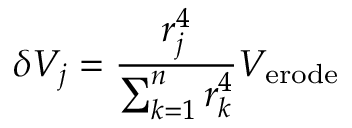Convert formula to latex. <formula><loc_0><loc_0><loc_500><loc_500>\delta V _ { j } = \frac { r _ { j } ^ { 4 } } { \sum _ { k = 1 } ^ { n } r _ { k } ^ { 4 } } V _ { e r o d e }</formula> 